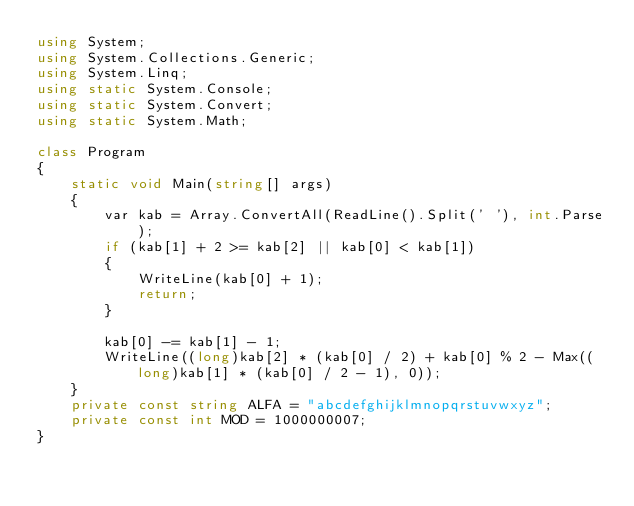Convert code to text. <code><loc_0><loc_0><loc_500><loc_500><_C#_>using System;
using System.Collections.Generic;
using System.Linq;
using static System.Console;
using static System.Convert;
using static System.Math;

class Program
{
    static void Main(string[] args)
    {
        var kab = Array.ConvertAll(ReadLine().Split(' '), int.Parse);
        if (kab[1] + 2 >= kab[2] || kab[0] < kab[1])
        {
            WriteLine(kab[0] + 1);
            return;
        }

        kab[0] -= kab[1] - 1;
        WriteLine((long)kab[2] * (kab[0] / 2) + kab[0] % 2 - Max((long)kab[1] * (kab[0] / 2 - 1), 0));
    }
    private const string ALFA = "abcdefghijklmnopqrstuvwxyz";
    private const int MOD = 1000000007;
}
</code> 